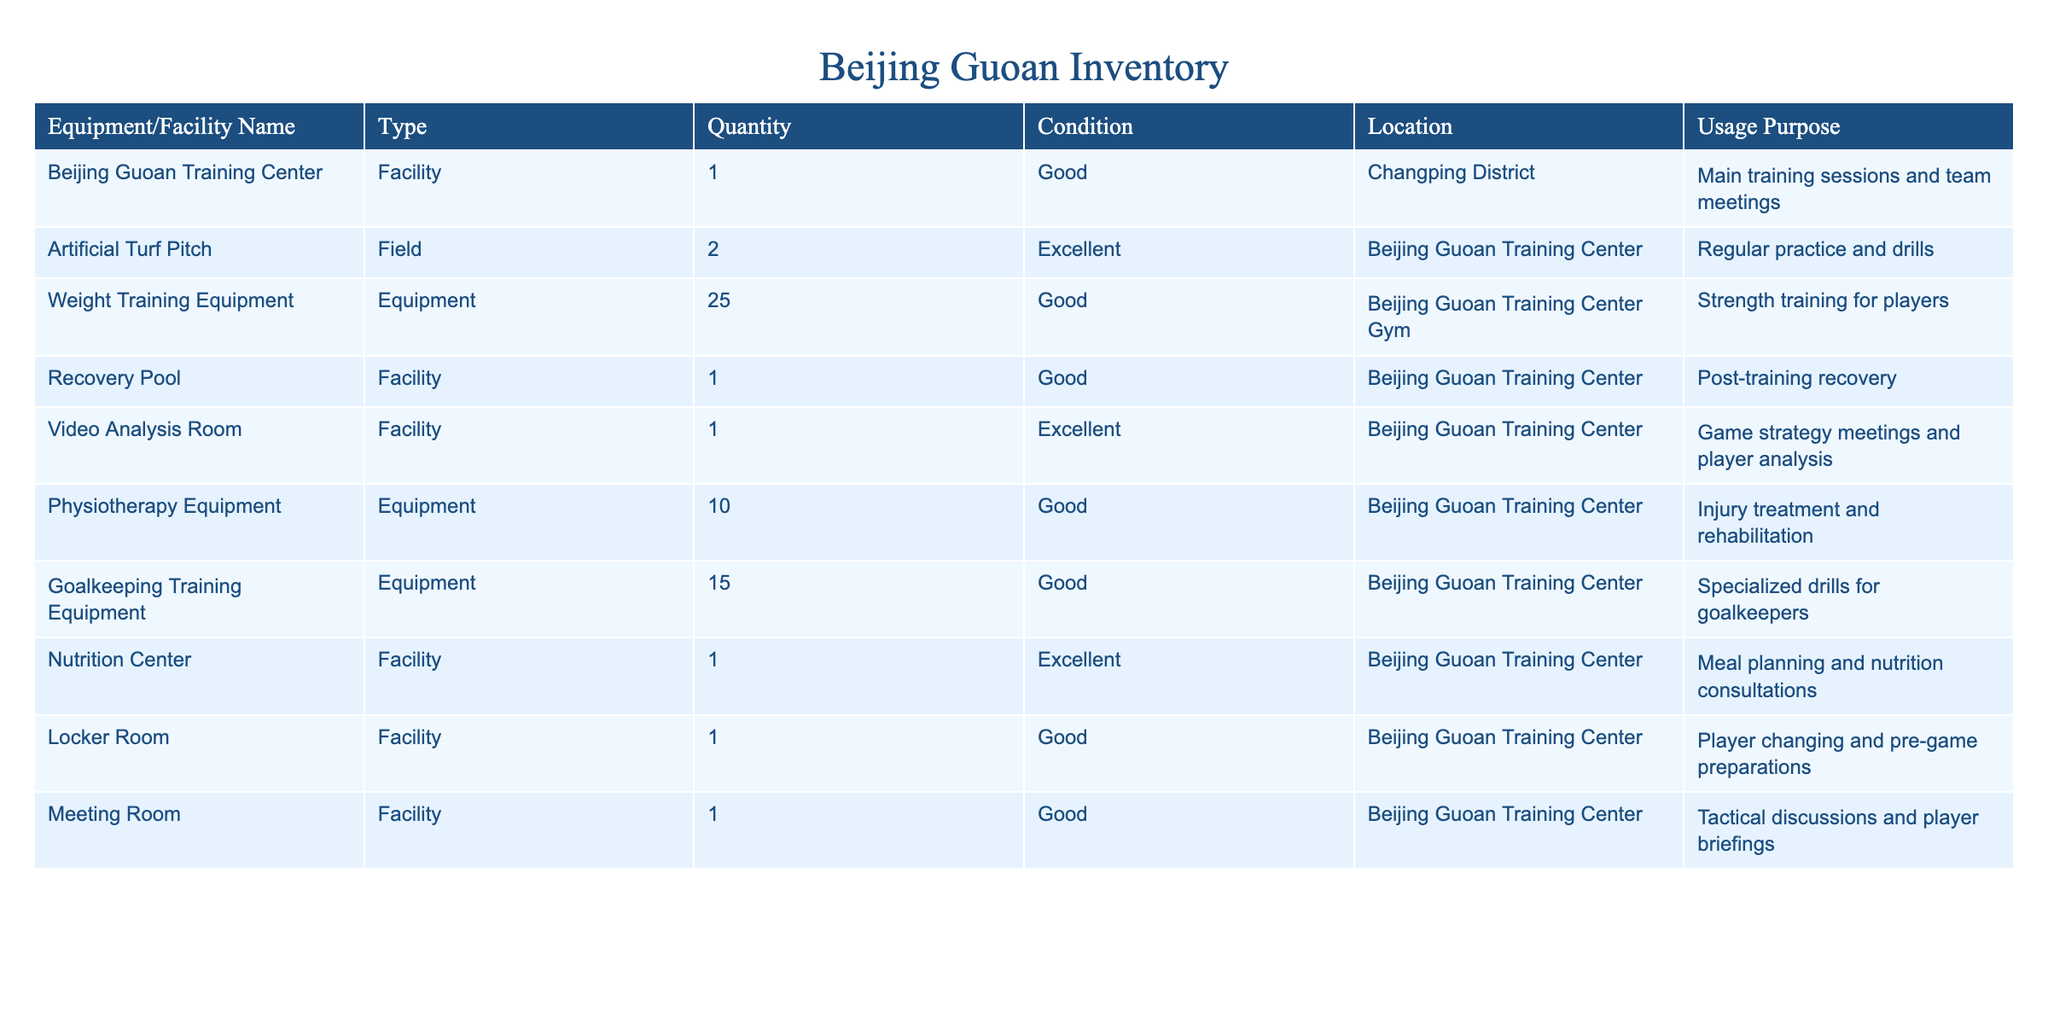What is the total quantity of training equipment listed in the table? The table lists different types of training equipment and their quantities. By adding up the quantities for Weight Training Equipment (25), Physiotherapy Equipment (10), Goalkeeping Training Equipment (15), the total is 25 + 10 + 15 = 50.
Answer: 50 How many facilities are classified as 'Good' in condition? The table has several facilities, and those in 'Good' condition include the Beijing Guoan Training Center, Recovery Pool, Locker Room, and Meeting Room. This gives a total of four facilities classified as 'Good'.
Answer: 4 Which equipment is specifically for goalkeepers? The table lists "Goalkeeping Training Equipment," which is specified for specialized drills for goalkeepers.
Answer: Goalkeeping Training Equipment Is the Nutrition Center in 'Excellent' condition? Yes, the table indicates that the Nutrition Center is classified as 'Excellent' in condition.
Answer: Yes What is the total number of fields in the inventory? The inventory indicates that there are two fields under the category of 'Artificial Turf Pitch.' Since this is the only entry under fields, the total is simply 2.
Answer: 2 What types of equipment are used for strength training? According to the table, the "Weight Training Equipment" is used for strength training, listed under equipment.
Answer: Weight Training Equipment Are there any facilities used for player analysis? Yes, the table mentions the "Video Analysis Room," which is used for game strategy meetings and player analysis.
Answer: Yes How many total training purposes are mentioned in the table? The table has various training purposes listed for each item. By reviewing the 'Usage Purpose' column, we find a unique count of six training purposes covering different aspects of training and recovery sessions.
Answer: 6 What is the location of the meeting room? The meeting room is located in the Beijing Guoan Training Center as specified in the table.
Answer: Beijing Guoan Training Center 